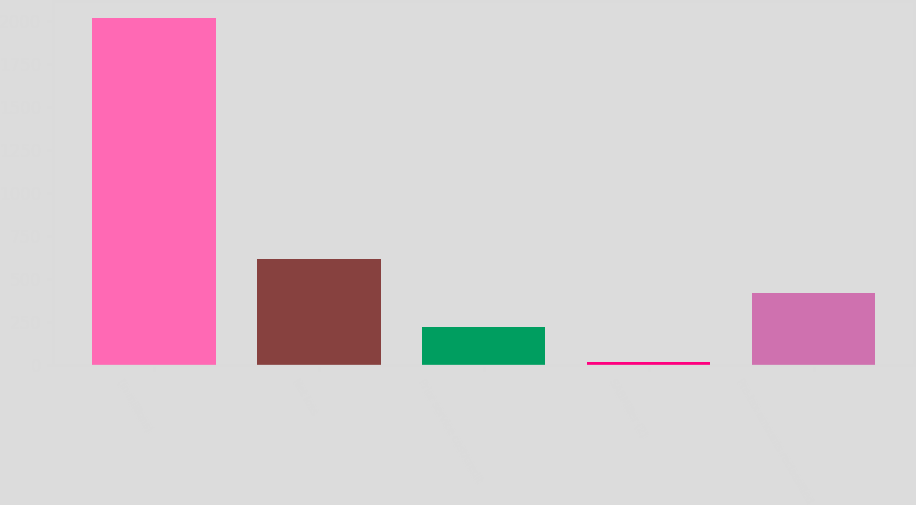Convert chart. <chart><loc_0><loc_0><loc_500><loc_500><bar_chart><fcel>(in millions)<fcel>Net loss<fcel>Prior service cost/credit<fcel>SABMiller (2)<fcel>Pre-tax amounts reclassified<nl><fcel>2015<fcel>619.2<fcel>220.4<fcel>21<fcel>419.8<nl></chart> 